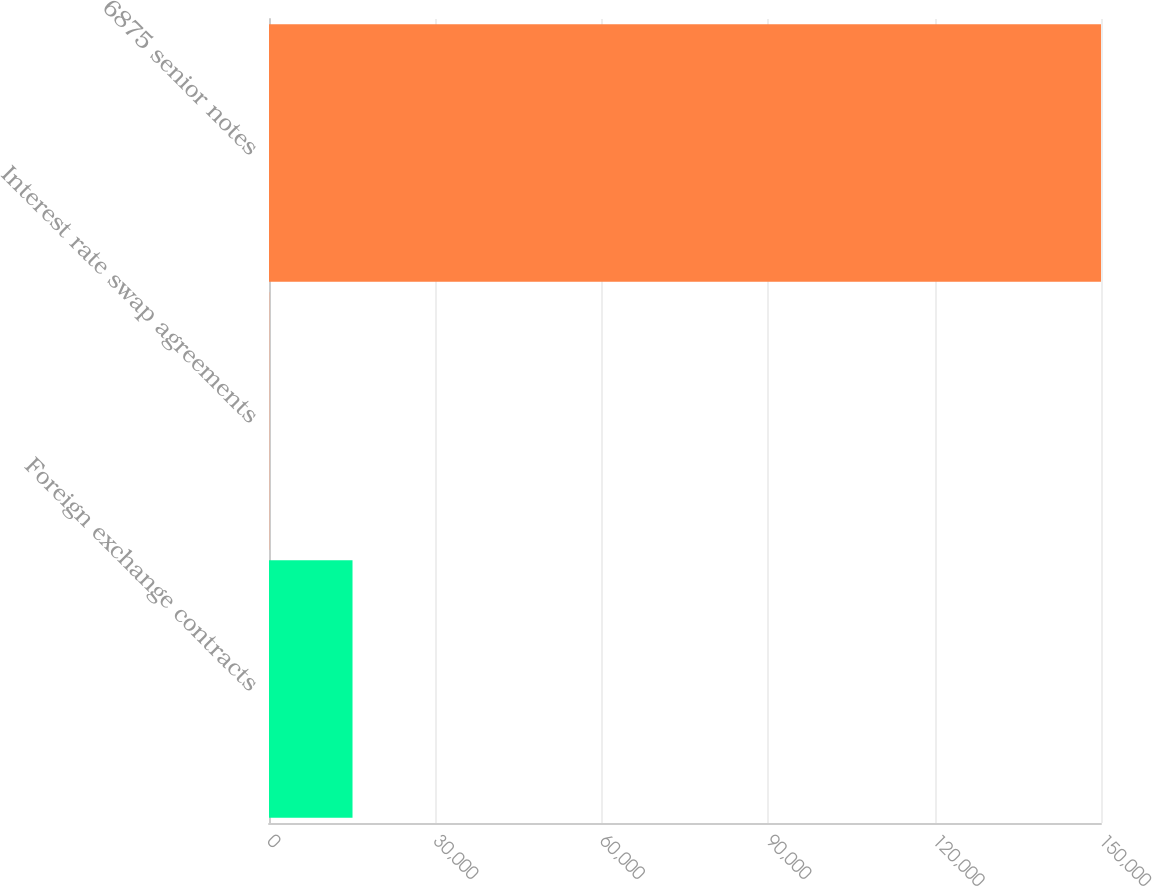Convert chart to OTSL. <chart><loc_0><loc_0><loc_500><loc_500><bar_chart><fcel>Foreign exchange contracts<fcel>Interest rate swap agreements<fcel>6875 senior notes<nl><fcel>15056.7<fcel>63<fcel>150000<nl></chart> 